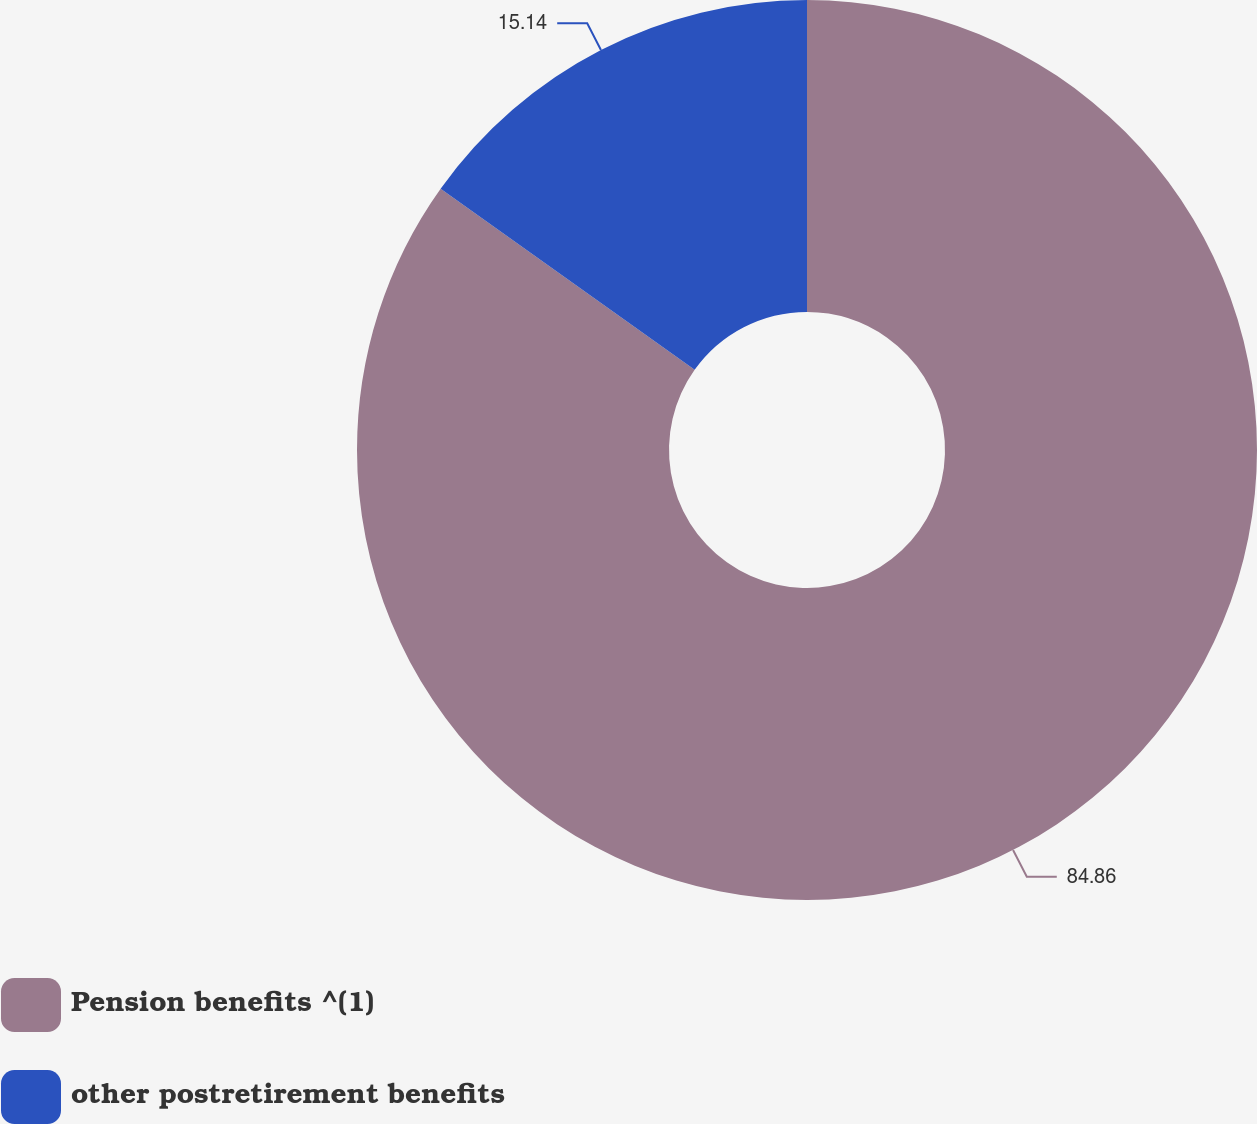<chart> <loc_0><loc_0><loc_500><loc_500><pie_chart><fcel>Pension benefits ^(1)<fcel>other postretirement benefits<nl><fcel>84.86%<fcel>15.14%<nl></chart> 